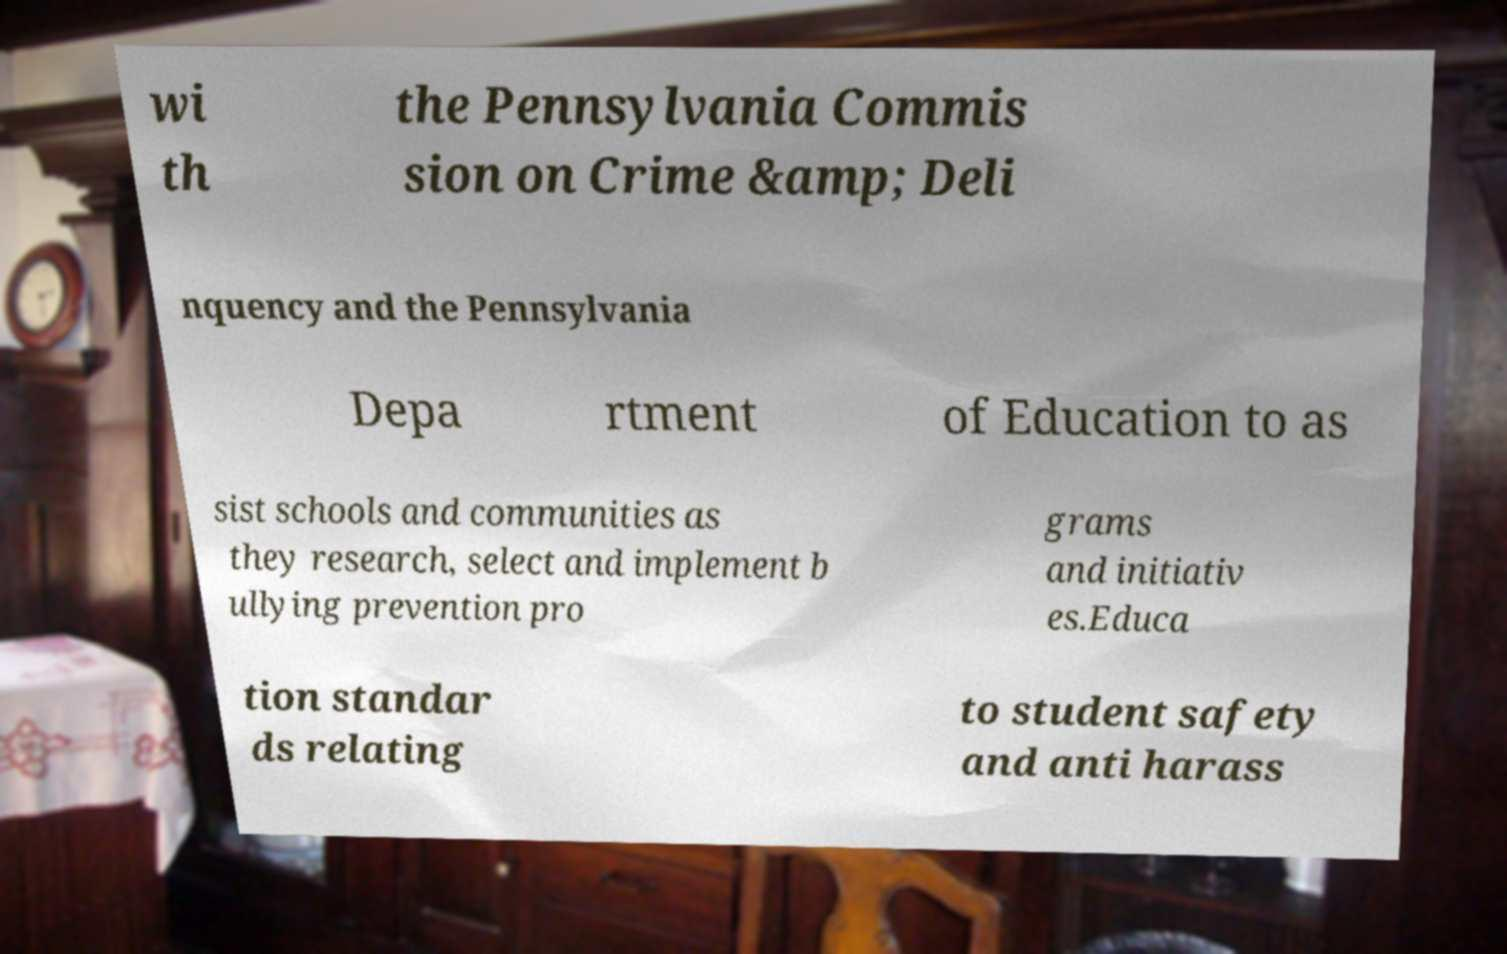Could you extract and type out the text from this image? wi th the Pennsylvania Commis sion on Crime &amp; Deli nquency and the Pennsylvania Depa rtment of Education to as sist schools and communities as they research, select and implement b ullying prevention pro grams and initiativ es.Educa tion standar ds relating to student safety and anti harass 